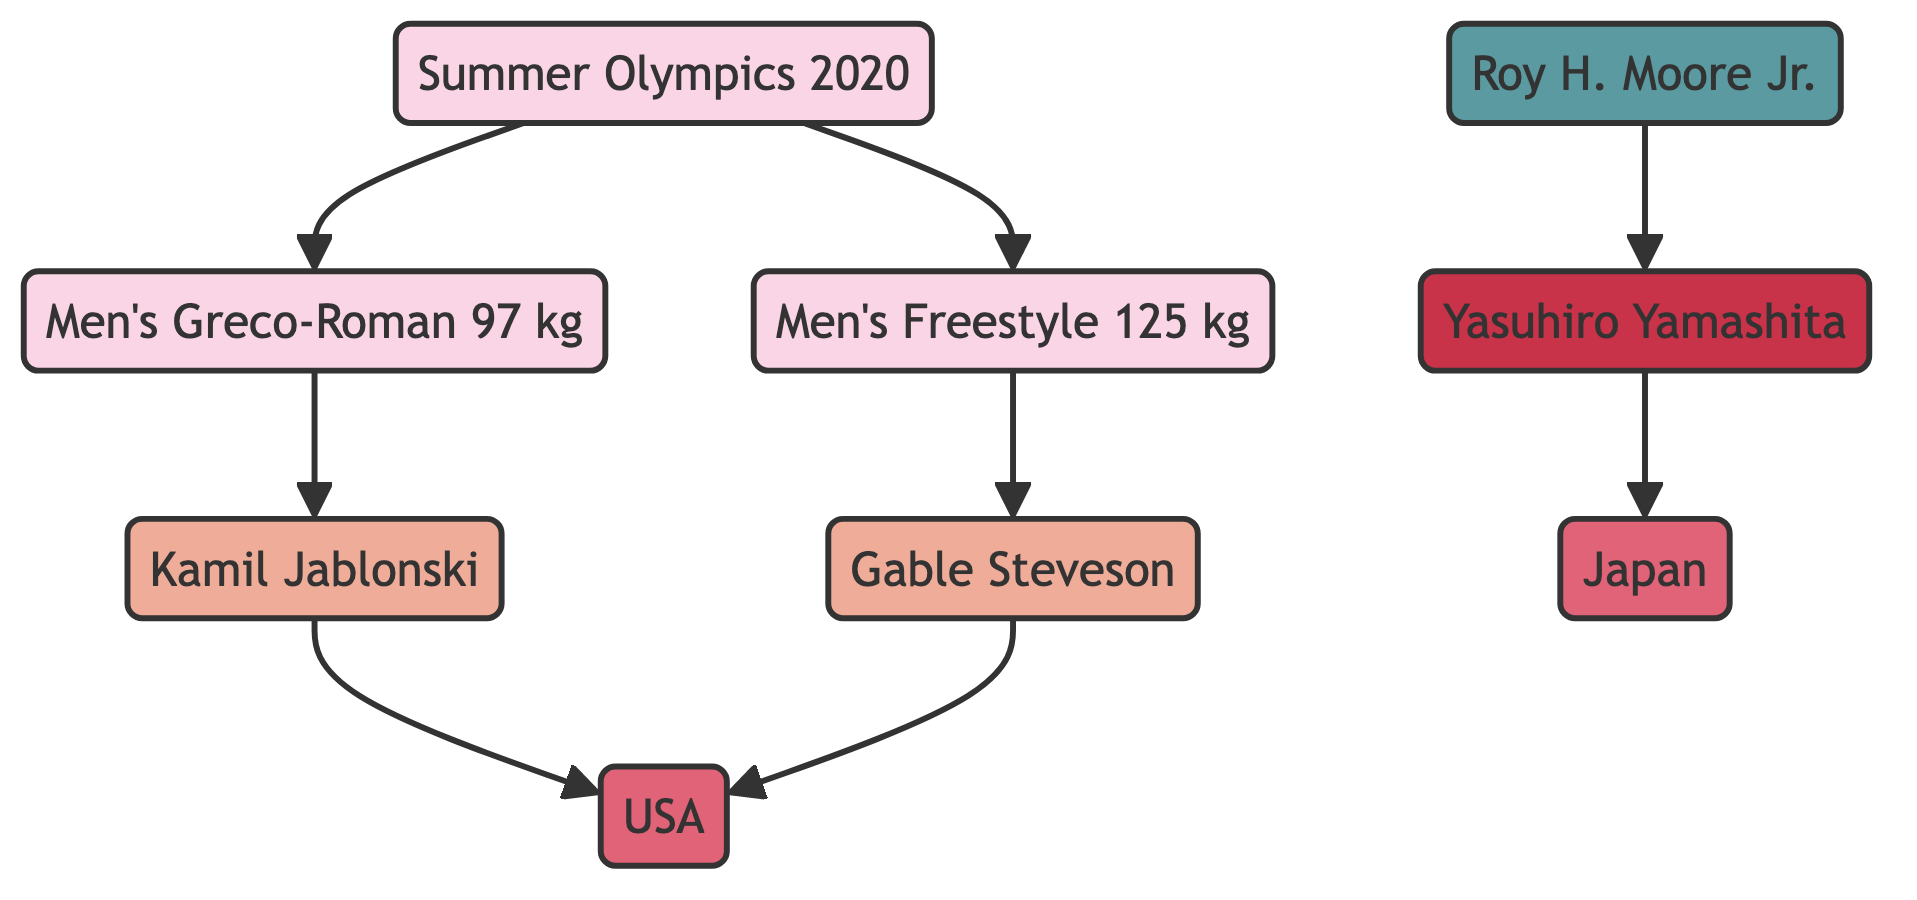What are the two wrestling events from the Summer Olympics 2020? The diagram shows two events connected to the "Summer Olympics 2020" node: "Men's Greco-Roman 97 kg" and "Men's Freestyle 125 kg."
Answer: Men's Greco-Roman 97 kg, Men's Freestyle 125 kg Which country is Kamil Jablonski representing? Kamil Jablonski is linked to the USA node, indicating that he represents the USA in wrestling competitions.
Answer: USA How many winners are listed in the diagram? There are two winners shown: "Kamil Jablonski" and "Gable Steveson." This is determined by counting the "Winner" nodes in the diagram.
Answer: 2 Who coached Yasuhiro Yamashita? The edge from "Roy H. Moore Jr." to "Yasuhiro Yamashita" indicates that Roy H. Moore Jr. is the coach associated with him.
Answer: Roy H. Moore Jr In which style did Gable Steveson compete? The edge connects "Gable Steveson" to "Men's Freestyle 125 kg," indicating that he competed in the freestyle wrestling style.
Answer: Freestyle What are the types of events in the Summer Olympics 2020 showcased in the diagram? The two types of events listed are "Men's Greco-Roman" and "Men's Freestyle." This can be confirmed by examining the edges connected to the "Summer Olympics 2020" node.
Answer: Men's Greco-Roman, Men's Freestyle Which country is associated with Yasuhiro Yamashita as indicated in the diagram? The edge from "Yasuhiro Yamashita" links to "Japan," indicating that he is associated with Japan in the context of wrestling.
Answer: Japan Which winner's event is linked to the Greco-Roman style? The diagram shows that "Kamil Jablonski" is the winner connected to "Men's Greco-Roman 97 kg," making him the winner in that style.
Answer: Kamil Jablonski How many edges are present in total? By counting all the edges connecting nodes in the diagram, there are eight edges indicating the relationships between the events, winners, and countries.
Answer: 8 